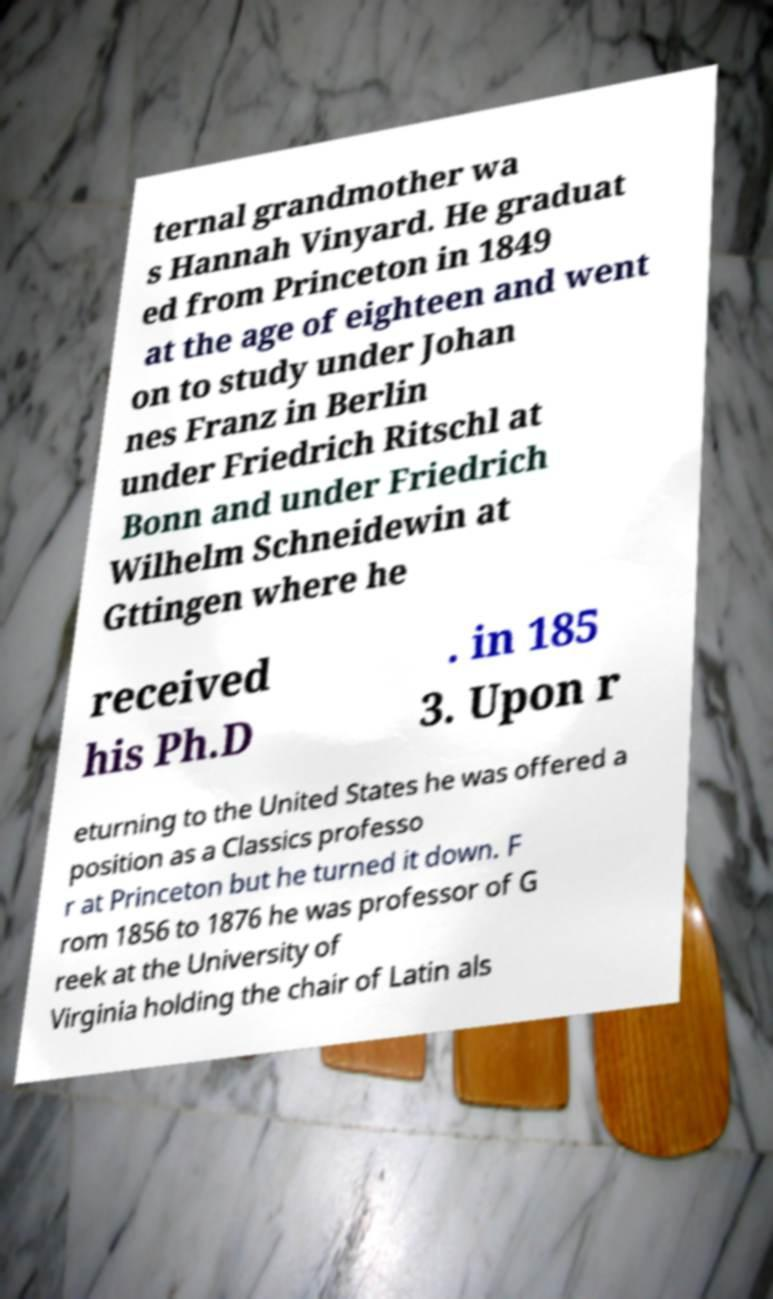Could you assist in decoding the text presented in this image and type it out clearly? ternal grandmother wa s Hannah Vinyard. He graduat ed from Princeton in 1849 at the age of eighteen and went on to study under Johan nes Franz in Berlin under Friedrich Ritschl at Bonn and under Friedrich Wilhelm Schneidewin at Gttingen where he received his Ph.D . in 185 3. Upon r eturning to the United States he was offered a position as a Classics professo r at Princeton but he turned it down. F rom 1856 to 1876 he was professor of G reek at the University of Virginia holding the chair of Latin als 